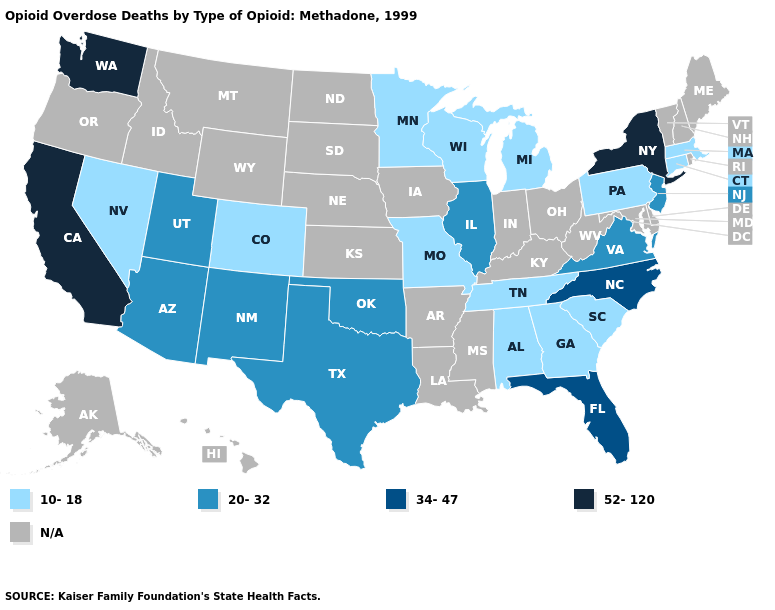Name the states that have a value in the range 20-32?
Keep it brief. Arizona, Illinois, New Jersey, New Mexico, Oklahoma, Texas, Utah, Virginia. What is the highest value in the West ?
Keep it brief. 52-120. What is the lowest value in states that border Tennessee?
Keep it brief. 10-18. What is the value of Oregon?
Keep it brief. N/A. What is the value of Louisiana?
Quick response, please. N/A. What is the value of Ohio?
Quick response, please. N/A. What is the value of Pennsylvania?
Give a very brief answer. 10-18. Does the map have missing data?
Write a very short answer. Yes. Name the states that have a value in the range N/A?
Answer briefly. Alaska, Arkansas, Delaware, Hawaii, Idaho, Indiana, Iowa, Kansas, Kentucky, Louisiana, Maine, Maryland, Mississippi, Montana, Nebraska, New Hampshire, North Dakota, Ohio, Oregon, Rhode Island, South Dakota, Vermont, West Virginia, Wyoming. Is the legend a continuous bar?
Be succinct. No. What is the lowest value in the West?
Keep it brief. 10-18. Which states hav the highest value in the South?
Give a very brief answer. Florida, North Carolina. What is the value of Hawaii?
Concise answer only. N/A. 